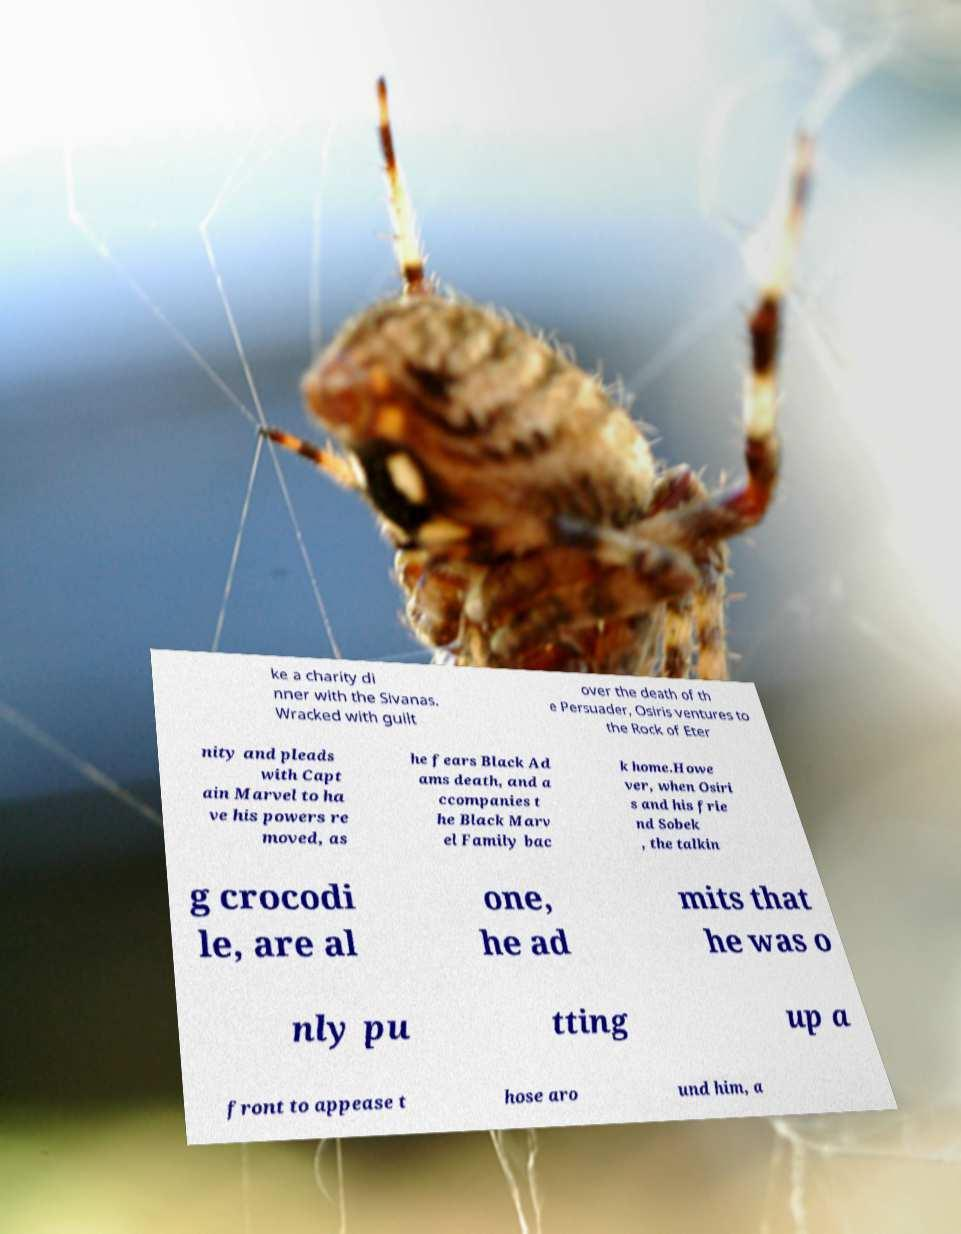I need the written content from this picture converted into text. Can you do that? ke a charity di nner with the Sivanas. Wracked with guilt over the death of th e Persuader, Osiris ventures to the Rock of Eter nity and pleads with Capt ain Marvel to ha ve his powers re moved, as he fears Black Ad ams death, and a ccompanies t he Black Marv el Family bac k home.Howe ver, when Osiri s and his frie nd Sobek , the talkin g crocodi le, are al one, he ad mits that he was o nly pu tting up a front to appease t hose aro und him, a 